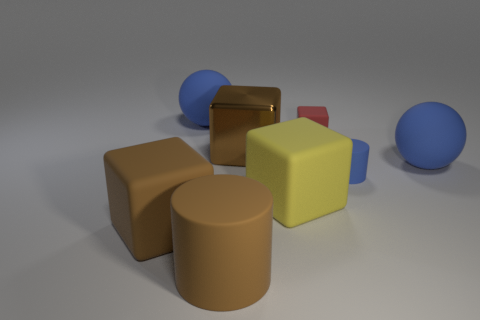There is a big matte object that is behind the small red matte thing; does it have the same shape as the matte thing that is on the right side of the blue cylinder?
Give a very brief answer. Yes. There is a blue object that is the same size as the red cube; what is its material?
Your answer should be compact. Rubber. Do the big sphere right of the brown metal cube and the tiny object to the right of the red block have the same material?
Provide a short and direct response. Yes. There is a brown metallic thing that is the same size as the brown rubber cylinder; what shape is it?
Ensure brevity in your answer.  Cube. What number of other things are there of the same color as the metallic block?
Provide a short and direct response. 2. What color is the rubber block that is behind the large yellow matte block?
Your answer should be very brief. Red. What number of other things are there of the same material as the red block
Your response must be concise. 6. Is the number of objects that are left of the red object greater than the number of rubber objects on the left side of the big brown shiny thing?
Your answer should be very brief. Yes. There is a brown rubber cube; how many brown rubber things are in front of it?
Make the answer very short. 1. Is the material of the yellow object the same as the big brown block right of the big brown cylinder?
Your response must be concise. No. 